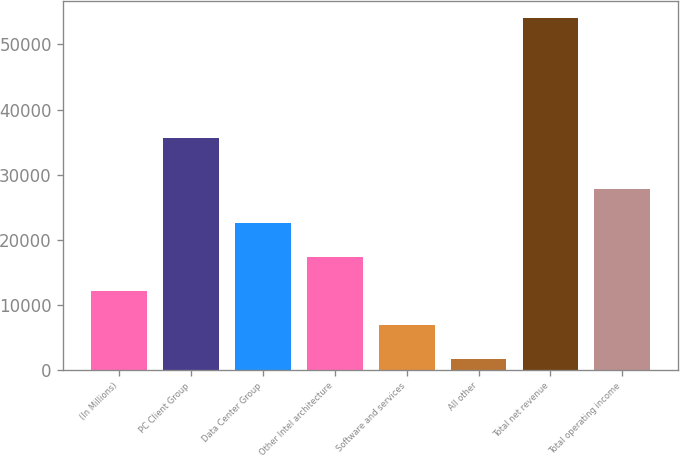<chart> <loc_0><loc_0><loc_500><loc_500><bar_chart><fcel>(In Millions)<fcel>PC Client Group<fcel>Data Center Group<fcel>Other Intel architecture<fcel>Software and services<fcel>All other<fcel>Total net revenue<fcel>Total operating income<nl><fcel>12071<fcel>35624<fcel>22553<fcel>17312<fcel>6830<fcel>1589<fcel>53999<fcel>27794<nl></chart> 